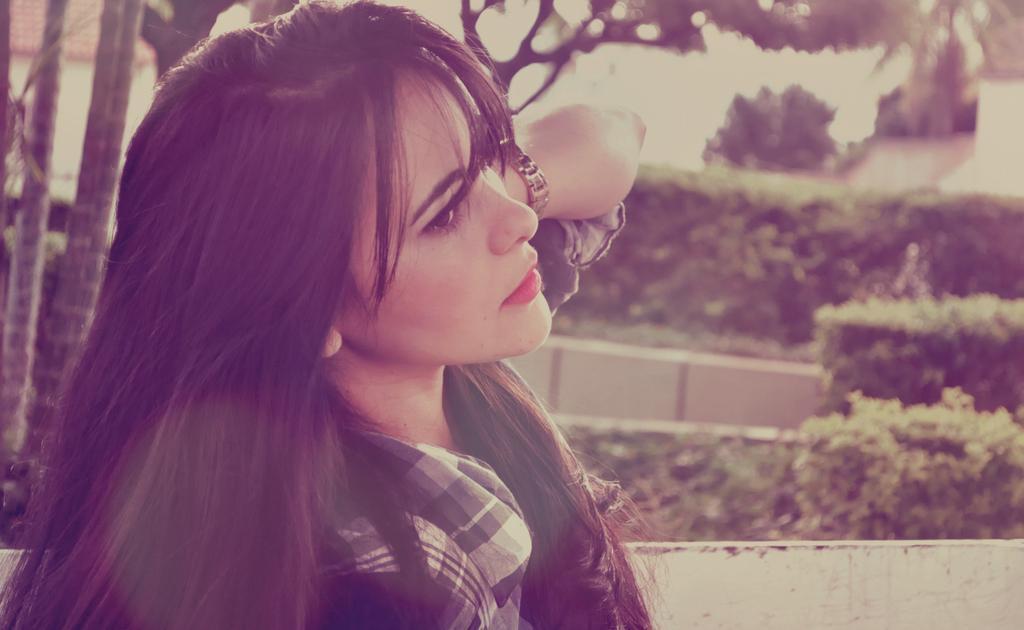Can you describe this image briefly? In this picture I can see a woman in front and in the background I can see few trees and plants and I see that it is a bit blurry on the top of this picture. 